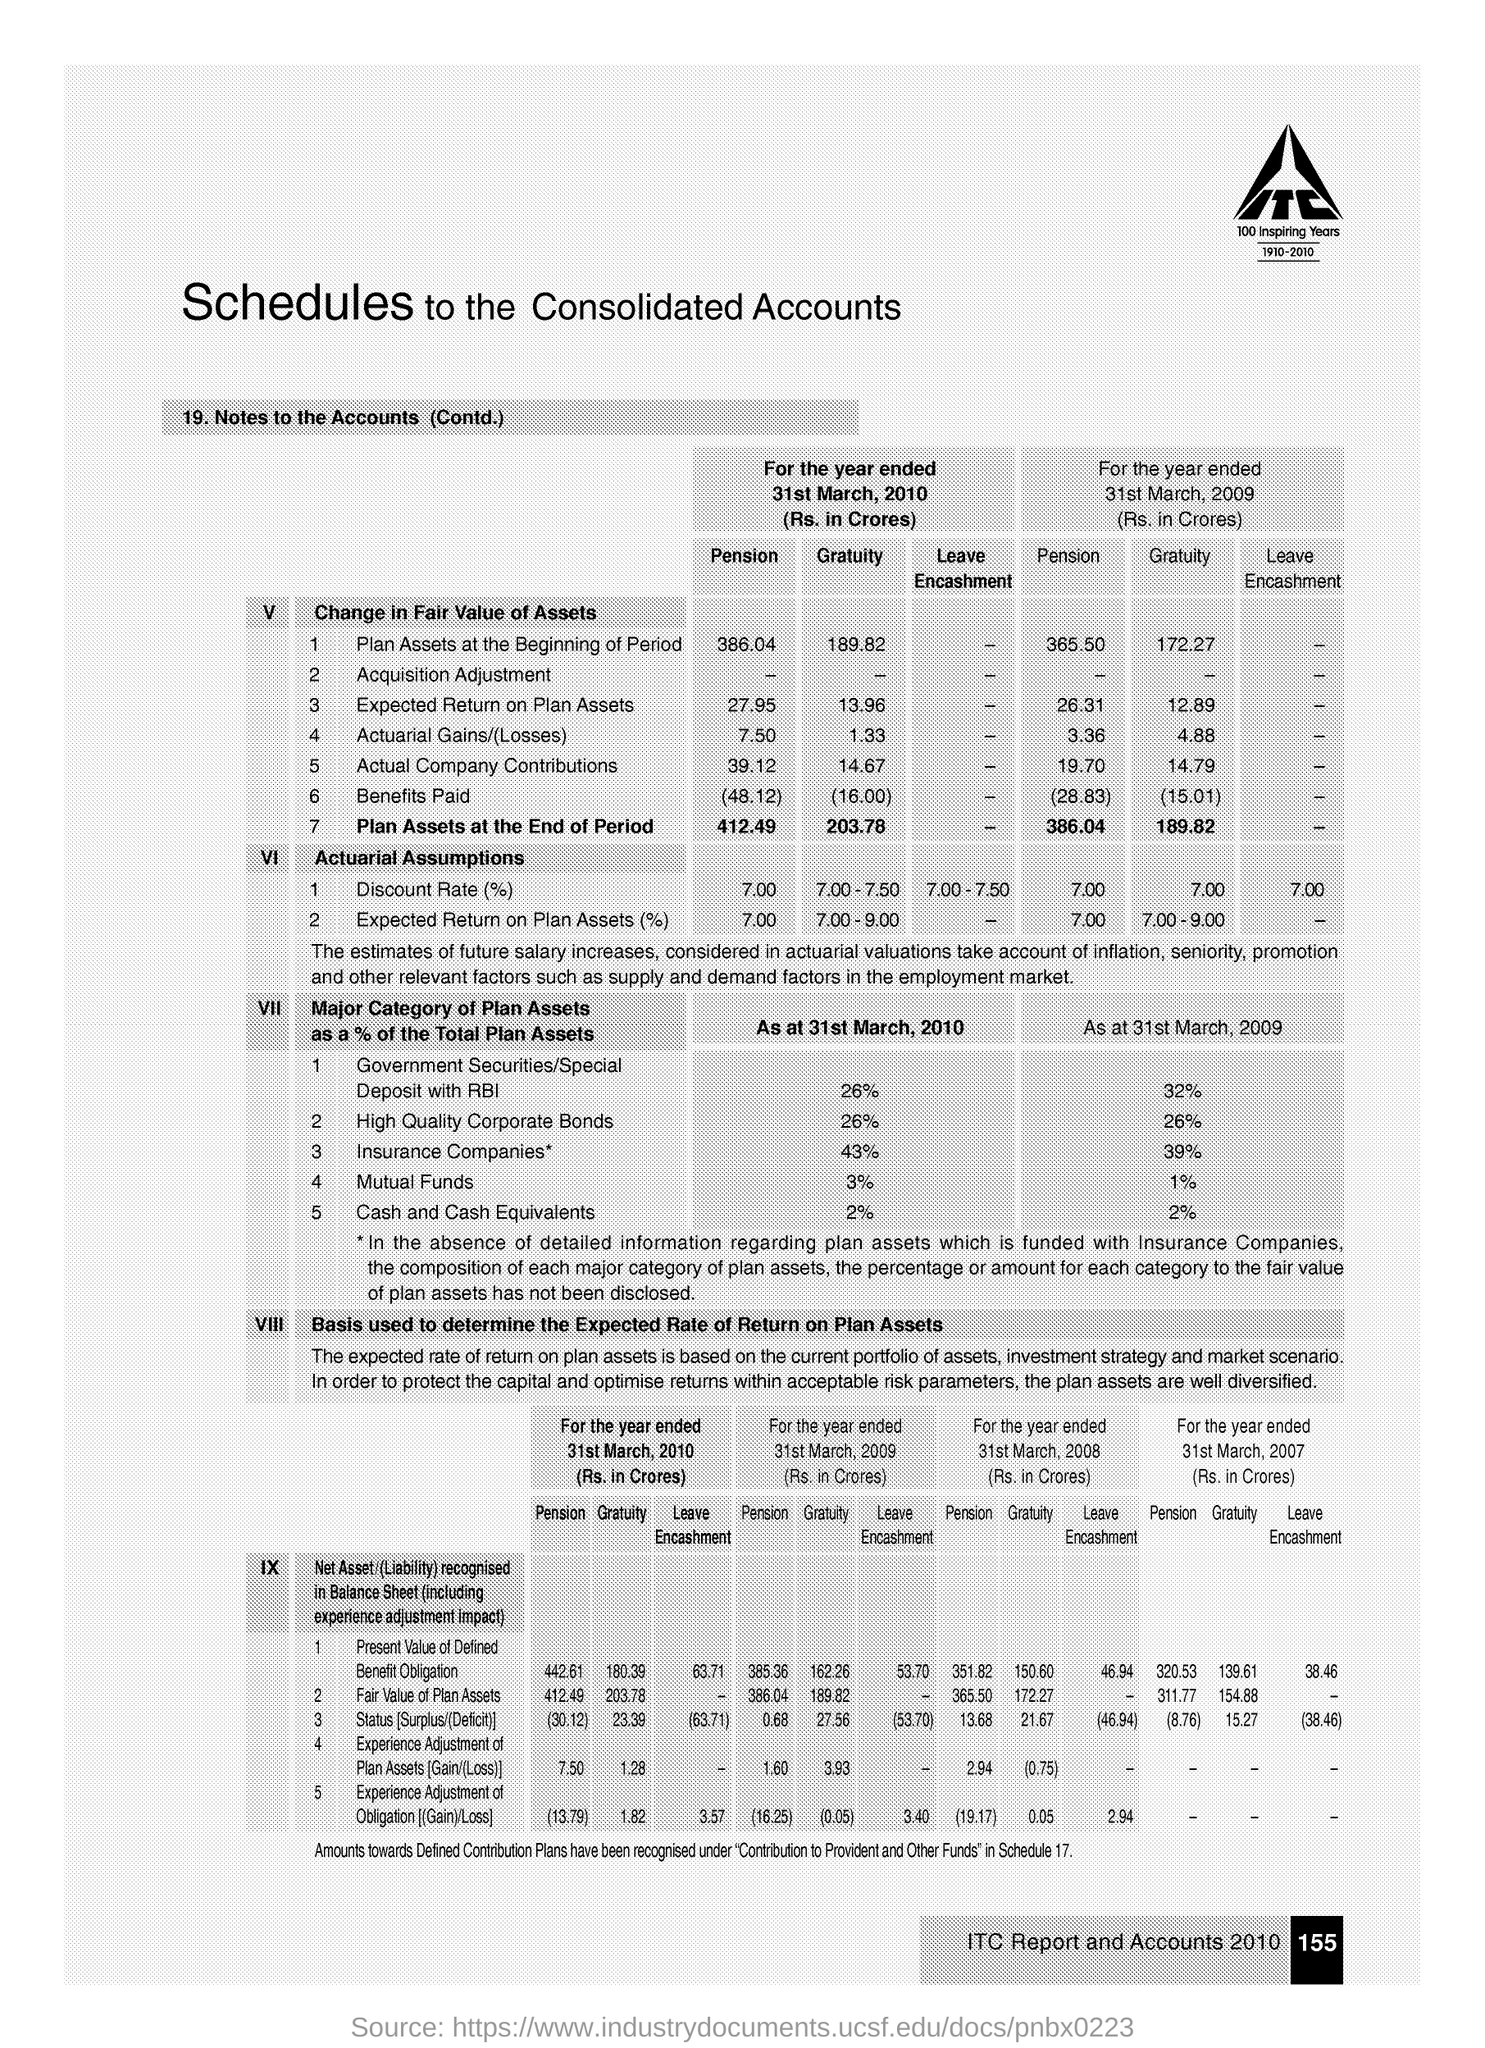What is the unit of pension for actuarial gains/(losses)  for the year ended in 2010?
Make the answer very short. 7.50. What is the percentage of Mutual funds of Total Plan Assets as at 31st March 2009?
Make the answer very short. 1%. 